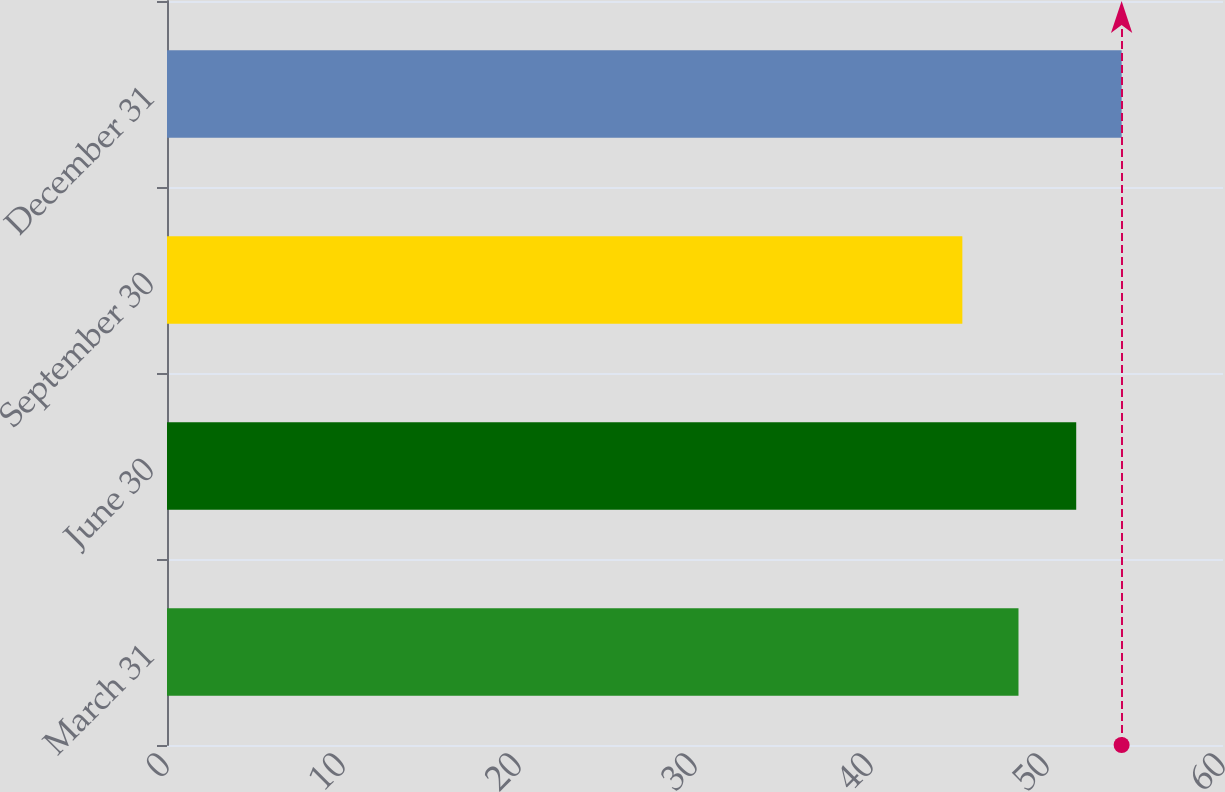<chart> <loc_0><loc_0><loc_500><loc_500><bar_chart><fcel>March 31<fcel>June 30<fcel>September 30<fcel>December 31<nl><fcel>48.38<fcel>51.66<fcel>45.19<fcel>54.24<nl></chart> 